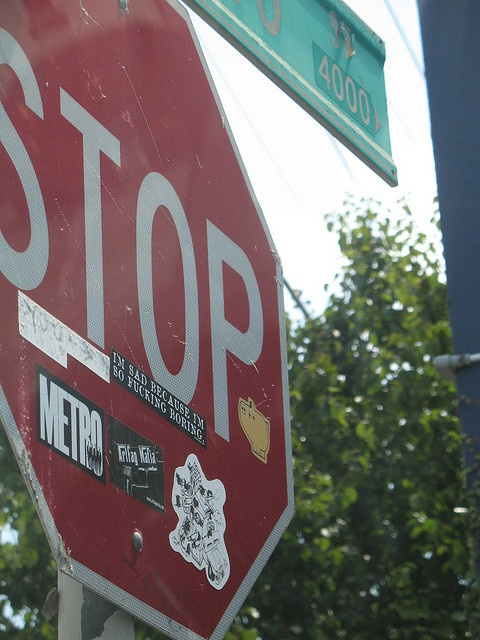Describe the objects in this image and their specific colors. I can see a stop sign in brown, maroon, and darkgray tones in this image. 